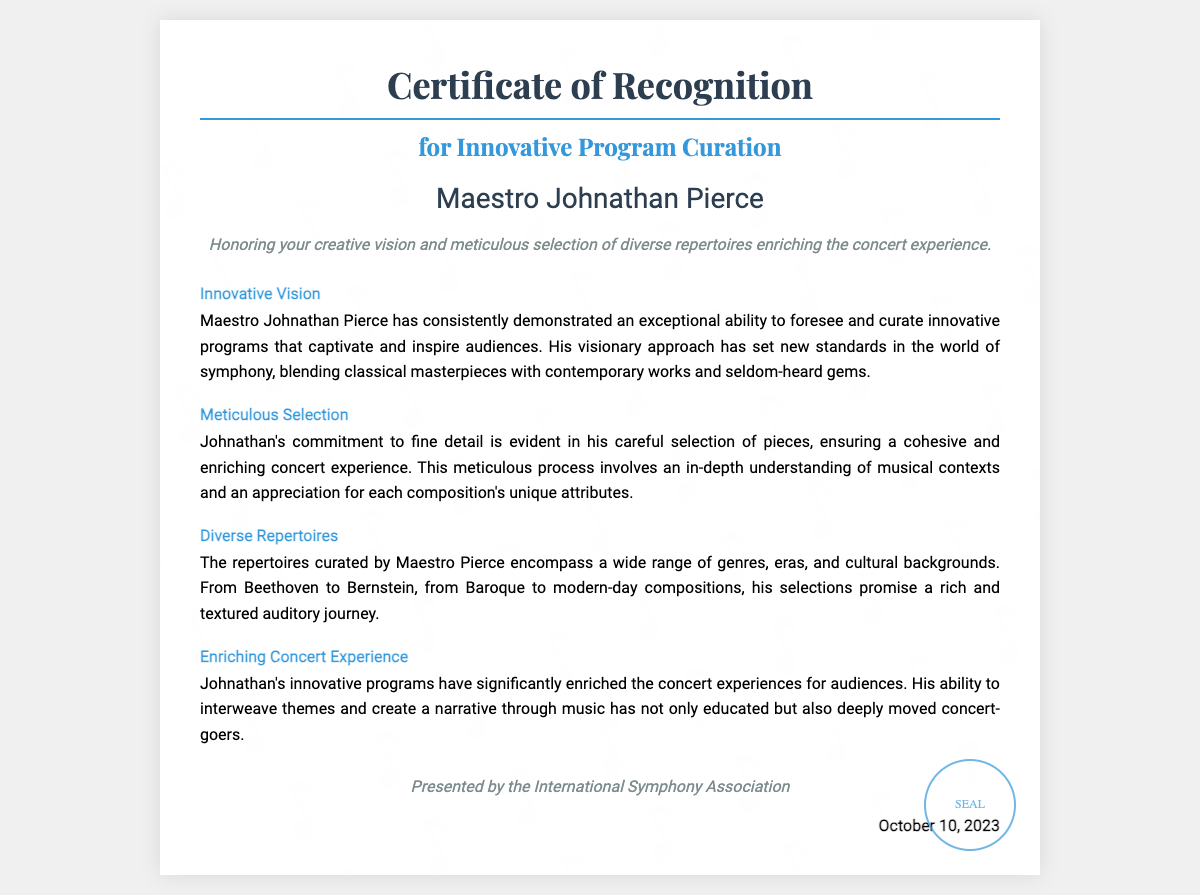What is the title of the certificate? The title of the certificate is prominently displayed at the top of the document, stating its purpose.
Answer: Certificate of Recognition for Innovative Program Curation Who is the recipient of the certificate? The recipient's name is featured prominently in the center of the certificate.
Answer: Maestro Johnathan Pierce What date is mentioned on the certificate? The certificate clearly states the date it was presented, located in a specific section of the document.
Answer: October 10, 2023 What organization presented the certificate? The presenting organization is mentioned at the bottom of the certificate, indicating its authority.
Answer: International Symphony Association What is honored in the certificate description? The description outlines the aspects of the recipient's work that are being acknowledged through the certificate.
Answer: Creative vision and meticulous selection of diverse repertoires What does the section on "Innovative Vision" highlight? This section of the certificate emphasizes a specific quality or ability of the recipient related to programming.
Answer: Exceptional ability to foresee and curate innovative programs How does the recipient ensure a cohesive concert experience? This question relates to the recipient's approach to selecting pieces for the concert, outlined in a specific section.
Answer: Careful selection of pieces What range of genres does the recipient include in the repertoires? This question focuses on the variety of music represented in the recipient's curated selections, as stated in the document.
Answer: Wide range of genres, eras, and cultural backgrounds What has Maestro Pierce's innovative programs significantly enriched? This inquiry targets the impact of the recipient's work on a specific aspect of the concert experience, shown in the document.
Answer: Concert experiences 